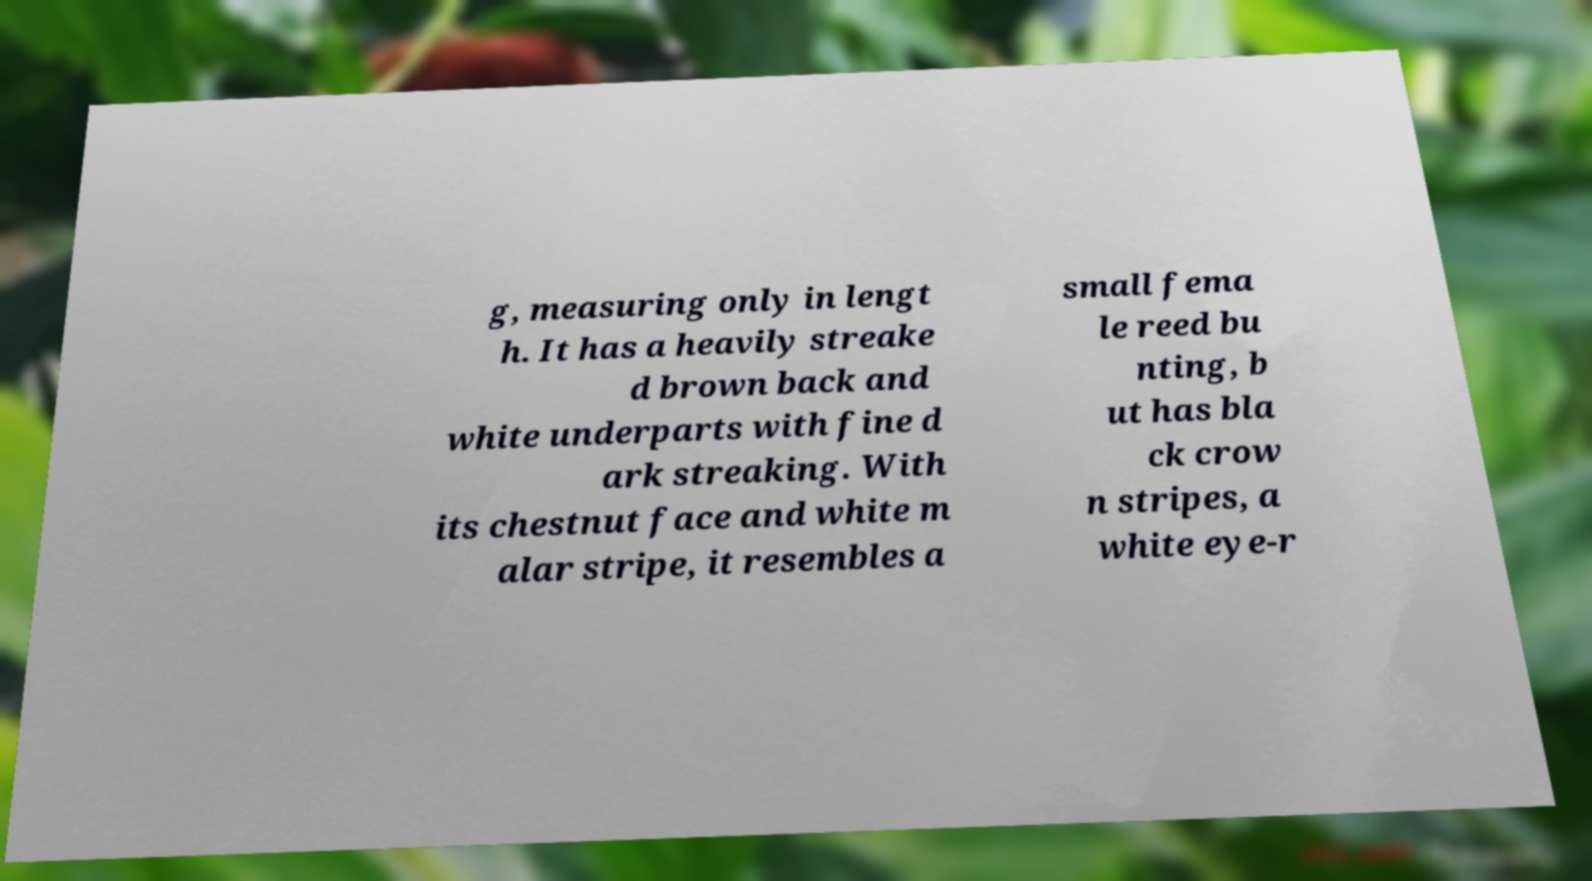What messages or text are displayed in this image? I need them in a readable, typed format. g, measuring only in lengt h. It has a heavily streake d brown back and white underparts with fine d ark streaking. With its chestnut face and white m alar stripe, it resembles a small fema le reed bu nting, b ut has bla ck crow n stripes, a white eye-r 